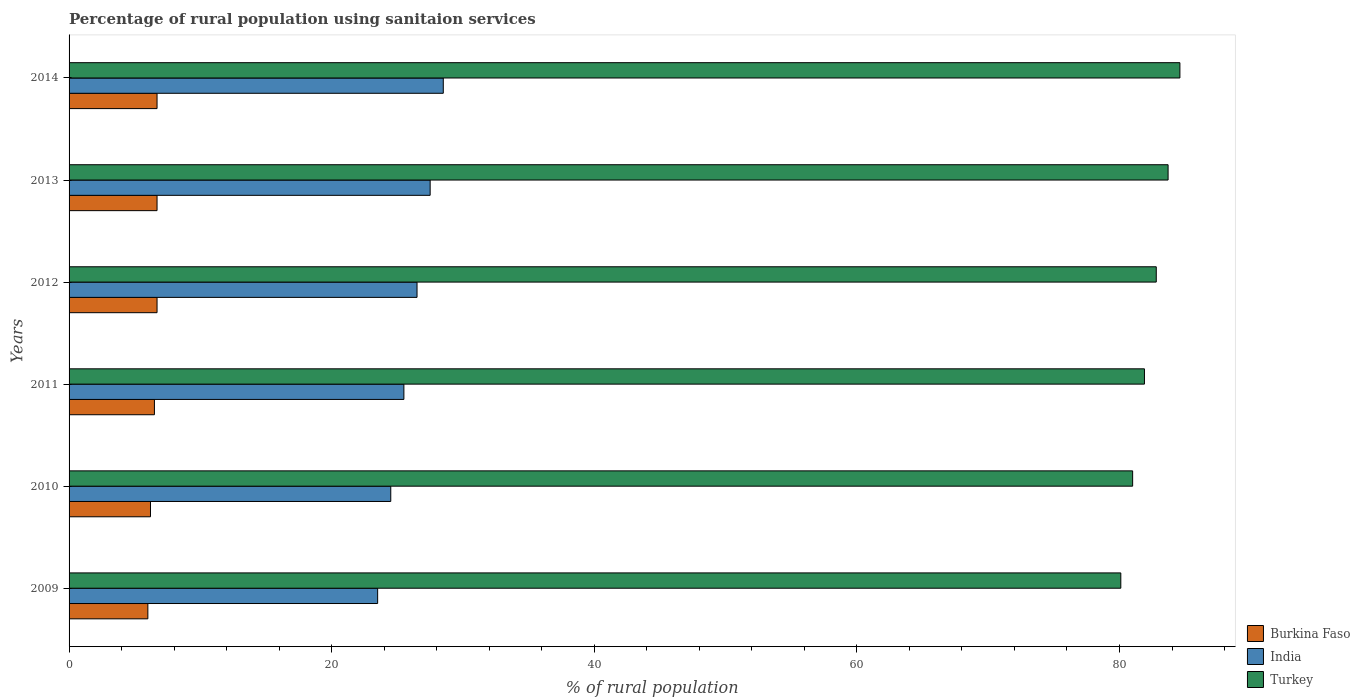Are the number of bars on each tick of the Y-axis equal?
Offer a terse response. Yes. How many bars are there on the 3rd tick from the top?
Your response must be concise. 3. In how many cases, is the number of bars for a given year not equal to the number of legend labels?
Ensure brevity in your answer.  0. What is the percentage of rural population using sanitaion services in India in 2012?
Provide a short and direct response. 26.5. Across all years, what is the maximum percentage of rural population using sanitaion services in Turkey?
Keep it short and to the point. 84.6. Across all years, what is the minimum percentage of rural population using sanitaion services in India?
Give a very brief answer. 23.5. What is the total percentage of rural population using sanitaion services in Burkina Faso in the graph?
Keep it short and to the point. 38.8. What is the difference between the percentage of rural population using sanitaion services in Burkina Faso in 2009 and the percentage of rural population using sanitaion services in Turkey in 2012?
Provide a succinct answer. -76.8. What is the average percentage of rural population using sanitaion services in India per year?
Provide a succinct answer. 26. In the year 2012, what is the difference between the percentage of rural population using sanitaion services in Turkey and percentage of rural population using sanitaion services in India?
Provide a short and direct response. 56.3. In how many years, is the percentage of rural population using sanitaion services in Turkey greater than 8 %?
Your response must be concise. 6. What is the ratio of the percentage of rural population using sanitaion services in Burkina Faso in 2010 to that in 2014?
Provide a short and direct response. 0.93. Is the percentage of rural population using sanitaion services in Burkina Faso in 2009 less than that in 2013?
Your response must be concise. Yes. Is the difference between the percentage of rural population using sanitaion services in Turkey in 2010 and 2011 greater than the difference between the percentage of rural population using sanitaion services in India in 2010 and 2011?
Provide a short and direct response. Yes. What is the difference between the highest and the second highest percentage of rural population using sanitaion services in Turkey?
Give a very brief answer. 0.9. What is the difference between the highest and the lowest percentage of rural population using sanitaion services in Burkina Faso?
Give a very brief answer. 0.7. What does the 1st bar from the bottom in 2013 represents?
Your response must be concise. Burkina Faso. Is it the case that in every year, the sum of the percentage of rural population using sanitaion services in India and percentage of rural population using sanitaion services in Burkina Faso is greater than the percentage of rural population using sanitaion services in Turkey?
Give a very brief answer. No. How many bars are there?
Provide a short and direct response. 18. Are all the bars in the graph horizontal?
Offer a terse response. Yes. What is the difference between two consecutive major ticks on the X-axis?
Make the answer very short. 20. Does the graph contain any zero values?
Ensure brevity in your answer.  No. Does the graph contain grids?
Ensure brevity in your answer.  No. Where does the legend appear in the graph?
Your answer should be compact. Bottom right. How are the legend labels stacked?
Offer a terse response. Vertical. What is the title of the graph?
Ensure brevity in your answer.  Percentage of rural population using sanitaion services. Does "World" appear as one of the legend labels in the graph?
Your answer should be very brief. No. What is the label or title of the X-axis?
Your answer should be compact. % of rural population. What is the label or title of the Y-axis?
Make the answer very short. Years. What is the % of rural population of India in 2009?
Provide a succinct answer. 23.5. What is the % of rural population of Turkey in 2009?
Give a very brief answer. 80.1. What is the % of rural population of India in 2010?
Your response must be concise. 24.5. What is the % of rural population in Turkey in 2011?
Ensure brevity in your answer.  81.9. What is the % of rural population in India in 2012?
Your answer should be very brief. 26.5. What is the % of rural population in Turkey in 2012?
Provide a succinct answer. 82.8. What is the % of rural population in Burkina Faso in 2013?
Your response must be concise. 6.7. What is the % of rural population of India in 2013?
Provide a succinct answer. 27.5. What is the % of rural population of Turkey in 2013?
Provide a succinct answer. 83.7. What is the % of rural population in India in 2014?
Offer a terse response. 28.5. What is the % of rural population in Turkey in 2014?
Ensure brevity in your answer.  84.6. Across all years, what is the maximum % of rural population of Turkey?
Offer a very short reply. 84.6. Across all years, what is the minimum % of rural population of Turkey?
Offer a very short reply. 80.1. What is the total % of rural population of Burkina Faso in the graph?
Your answer should be very brief. 38.8. What is the total % of rural population in India in the graph?
Provide a succinct answer. 156. What is the total % of rural population of Turkey in the graph?
Keep it short and to the point. 494.1. What is the difference between the % of rural population of India in 2009 and that in 2010?
Offer a very short reply. -1. What is the difference between the % of rural population of Turkey in 2009 and that in 2010?
Offer a terse response. -0.9. What is the difference between the % of rural population in Burkina Faso in 2009 and that in 2011?
Make the answer very short. -0.5. What is the difference between the % of rural population of Turkey in 2009 and that in 2011?
Provide a short and direct response. -1.8. What is the difference between the % of rural population of Burkina Faso in 2009 and that in 2012?
Your response must be concise. -0.7. What is the difference between the % of rural population in India in 2009 and that in 2012?
Make the answer very short. -3. What is the difference between the % of rural population of Turkey in 2009 and that in 2012?
Ensure brevity in your answer.  -2.7. What is the difference between the % of rural population of Turkey in 2009 and that in 2013?
Your answer should be compact. -3.6. What is the difference between the % of rural population of Turkey in 2009 and that in 2014?
Your response must be concise. -4.5. What is the difference between the % of rural population of Burkina Faso in 2010 and that in 2011?
Provide a short and direct response. -0.3. What is the difference between the % of rural population in India in 2010 and that in 2011?
Give a very brief answer. -1. What is the difference between the % of rural population in India in 2010 and that in 2012?
Your answer should be compact. -2. What is the difference between the % of rural population in Burkina Faso in 2010 and that in 2013?
Your answer should be very brief. -0.5. What is the difference between the % of rural population of India in 2010 and that in 2013?
Give a very brief answer. -3. What is the difference between the % of rural population in Burkina Faso in 2010 and that in 2014?
Keep it short and to the point. -0.5. What is the difference between the % of rural population in Burkina Faso in 2011 and that in 2012?
Keep it short and to the point. -0.2. What is the difference between the % of rural population of Turkey in 2011 and that in 2013?
Give a very brief answer. -1.8. What is the difference between the % of rural population in India in 2011 and that in 2014?
Your answer should be compact. -3. What is the difference between the % of rural population of Burkina Faso in 2012 and that in 2014?
Offer a terse response. 0. What is the difference between the % of rural population in Burkina Faso in 2013 and that in 2014?
Keep it short and to the point. 0. What is the difference between the % of rural population of India in 2013 and that in 2014?
Ensure brevity in your answer.  -1. What is the difference between the % of rural population in Burkina Faso in 2009 and the % of rural population in India in 2010?
Provide a succinct answer. -18.5. What is the difference between the % of rural population in Burkina Faso in 2009 and the % of rural population in Turkey in 2010?
Keep it short and to the point. -75. What is the difference between the % of rural population in India in 2009 and the % of rural population in Turkey in 2010?
Your response must be concise. -57.5. What is the difference between the % of rural population of Burkina Faso in 2009 and the % of rural population of India in 2011?
Offer a terse response. -19.5. What is the difference between the % of rural population in Burkina Faso in 2009 and the % of rural population in Turkey in 2011?
Your answer should be very brief. -75.9. What is the difference between the % of rural population of India in 2009 and the % of rural population of Turkey in 2011?
Your answer should be very brief. -58.4. What is the difference between the % of rural population of Burkina Faso in 2009 and the % of rural population of India in 2012?
Your answer should be compact. -20.5. What is the difference between the % of rural population of Burkina Faso in 2009 and the % of rural population of Turkey in 2012?
Your response must be concise. -76.8. What is the difference between the % of rural population of India in 2009 and the % of rural population of Turkey in 2012?
Ensure brevity in your answer.  -59.3. What is the difference between the % of rural population of Burkina Faso in 2009 and the % of rural population of India in 2013?
Your answer should be compact. -21.5. What is the difference between the % of rural population of Burkina Faso in 2009 and the % of rural population of Turkey in 2013?
Provide a short and direct response. -77.7. What is the difference between the % of rural population in India in 2009 and the % of rural population in Turkey in 2013?
Provide a succinct answer. -60.2. What is the difference between the % of rural population in Burkina Faso in 2009 and the % of rural population in India in 2014?
Give a very brief answer. -22.5. What is the difference between the % of rural population of Burkina Faso in 2009 and the % of rural population of Turkey in 2014?
Offer a terse response. -78.6. What is the difference between the % of rural population of India in 2009 and the % of rural population of Turkey in 2014?
Ensure brevity in your answer.  -61.1. What is the difference between the % of rural population of Burkina Faso in 2010 and the % of rural population of India in 2011?
Offer a very short reply. -19.3. What is the difference between the % of rural population of Burkina Faso in 2010 and the % of rural population of Turkey in 2011?
Your answer should be compact. -75.7. What is the difference between the % of rural population in India in 2010 and the % of rural population in Turkey in 2011?
Provide a succinct answer. -57.4. What is the difference between the % of rural population of Burkina Faso in 2010 and the % of rural population of India in 2012?
Provide a short and direct response. -20.3. What is the difference between the % of rural population of Burkina Faso in 2010 and the % of rural population of Turkey in 2012?
Your response must be concise. -76.6. What is the difference between the % of rural population of India in 2010 and the % of rural population of Turkey in 2012?
Keep it short and to the point. -58.3. What is the difference between the % of rural population of Burkina Faso in 2010 and the % of rural population of India in 2013?
Your answer should be compact. -21.3. What is the difference between the % of rural population in Burkina Faso in 2010 and the % of rural population in Turkey in 2013?
Ensure brevity in your answer.  -77.5. What is the difference between the % of rural population in India in 2010 and the % of rural population in Turkey in 2013?
Keep it short and to the point. -59.2. What is the difference between the % of rural population of Burkina Faso in 2010 and the % of rural population of India in 2014?
Your answer should be very brief. -22.3. What is the difference between the % of rural population of Burkina Faso in 2010 and the % of rural population of Turkey in 2014?
Give a very brief answer. -78.4. What is the difference between the % of rural population in India in 2010 and the % of rural population in Turkey in 2014?
Ensure brevity in your answer.  -60.1. What is the difference between the % of rural population in Burkina Faso in 2011 and the % of rural population in Turkey in 2012?
Your response must be concise. -76.3. What is the difference between the % of rural population in India in 2011 and the % of rural population in Turkey in 2012?
Provide a short and direct response. -57.3. What is the difference between the % of rural population in Burkina Faso in 2011 and the % of rural population in India in 2013?
Provide a short and direct response. -21. What is the difference between the % of rural population in Burkina Faso in 2011 and the % of rural population in Turkey in 2013?
Your answer should be compact. -77.2. What is the difference between the % of rural population of India in 2011 and the % of rural population of Turkey in 2013?
Ensure brevity in your answer.  -58.2. What is the difference between the % of rural population of Burkina Faso in 2011 and the % of rural population of Turkey in 2014?
Offer a terse response. -78.1. What is the difference between the % of rural population in India in 2011 and the % of rural population in Turkey in 2014?
Offer a very short reply. -59.1. What is the difference between the % of rural population of Burkina Faso in 2012 and the % of rural population of India in 2013?
Keep it short and to the point. -20.8. What is the difference between the % of rural population of Burkina Faso in 2012 and the % of rural population of Turkey in 2013?
Keep it short and to the point. -77. What is the difference between the % of rural population of India in 2012 and the % of rural population of Turkey in 2013?
Provide a succinct answer. -57.2. What is the difference between the % of rural population in Burkina Faso in 2012 and the % of rural population in India in 2014?
Your answer should be compact. -21.8. What is the difference between the % of rural population of Burkina Faso in 2012 and the % of rural population of Turkey in 2014?
Give a very brief answer. -77.9. What is the difference between the % of rural population in India in 2012 and the % of rural population in Turkey in 2014?
Your answer should be compact. -58.1. What is the difference between the % of rural population in Burkina Faso in 2013 and the % of rural population in India in 2014?
Give a very brief answer. -21.8. What is the difference between the % of rural population in Burkina Faso in 2013 and the % of rural population in Turkey in 2014?
Keep it short and to the point. -77.9. What is the difference between the % of rural population in India in 2013 and the % of rural population in Turkey in 2014?
Provide a short and direct response. -57.1. What is the average % of rural population in Burkina Faso per year?
Keep it short and to the point. 6.47. What is the average % of rural population in Turkey per year?
Provide a short and direct response. 82.35. In the year 2009, what is the difference between the % of rural population in Burkina Faso and % of rural population in India?
Ensure brevity in your answer.  -17.5. In the year 2009, what is the difference between the % of rural population in Burkina Faso and % of rural population in Turkey?
Your answer should be very brief. -74.1. In the year 2009, what is the difference between the % of rural population of India and % of rural population of Turkey?
Provide a short and direct response. -56.6. In the year 2010, what is the difference between the % of rural population of Burkina Faso and % of rural population of India?
Offer a terse response. -18.3. In the year 2010, what is the difference between the % of rural population in Burkina Faso and % of rural population in Turkey?
Ensure brevity in your answer.  -74.8. In the year 2010, what is the difference between the % of rural population in India and % of rural population in Turkey?
Give a very brief answer. -56.5. In the year 2011, what is the difference between the % of rural population in Burkina Faso and % of rural population in India?
Provide a short and direct response. -19. In the year 2011, what is the difference between the % of rural population in Burkina Faso and % of rural population in Turkey?
Your answer should be very brief. -75.4. In the year 2011, what is the difference between the % of rural population of India and % of rural population of Turkey?
Your answer should be compact. -56.4. In the year 2012, what is the difference between the % of rural population of Burkina Faso and % of rural population of India?
Give a very brief answer. -19.8. In the year 2012, what is the difference between the % of rural population of Burkina Faso and % of rural population of Turkey?
Your response must be concise. -76.1. In the year 2012, what is the difference between the % of rural population in India and % of rural population in Turkey?
Your answer should be compact. -56.3. In the year 2013, what is the difference between the % of rural population in Burkina Faso and % of rural population in India?
Provide a succinct answer. -20.8. In the year 2013, what is the difference between the % of rural population of Burkina Faso and % of rural population of Turkey?
Your answer should be compact. -77. In the year 2013, what is the difference between the % of rural population of India and % of rural population of Turkey?
Your answer should be very brief. -56.2. In the year 2014, what is the difference between the % of rural population of Burkina Faso and % of rural population of India?
Your answer should be very brief. -21.8. In the year 2014, what is the difference between the % of rural population of Burkina Faso and % of rural population of Turkey?
Your answer should be compact. -77.9. In the year 2014, what is the difference between the % of rural population of India and % of rural population of Turkey?
Ensure brevity in your answer.  -56.1. What is the ratio of the % of rural population of India in 2009 to that in 2010?
Your response must be concise. 0.96. What is the ratio of the % of rural population of Turkey in 2009 to that in 2010?
Your answer should be very brief. 0.99. What is the ratio of the % of rural population in Burkina Faso in 2009 to that in 2011?
Offer a terse response. 0.92. What is the ratio of the % of rural population in India in 2009 to that in 2011?
Ensure brevity in your answer.  0.92. What is the ratio of the % of rural population of Burkina Faso in 2009 to that in 2012?
Provide a succinct answer. 0.9. What is the ratio of the % of rural population in India in 2009 to that in 2012?
Give a very brief answer. 0.89. What is the ratio of the % of rural population in Turkey in 2009 to that in 2012?
Your response must be concise. 0.97. What is the ratio of the % of rural population in Burkina Faso in 2009 to that in 2013?
Provide a short and direct response. 0.9. What is the ratio of the % of rural population of India in 2009 to that in 2013?
Offer a very short reply. 0.85. What is the ratio of the % of rural population in Turkey in 2009 to that in 2013?
Provide a succinct answer. 0.96. What is the ratio of the % of rural population in Burkina Faso in 2009 to that in 2014?
Offer a very short reply. 0.9. What is the ratio of the % of rural population in India in 2009 to that in 2014?
Your response must be concise. 0.82. What is the ratio of the % of rural population in Turkey in 2009 to that in 2014?
Provide a short and direct response. 0.95. What is the ratio of the % of rural population of Burkina Faso in 2010 to that in 2011?
Provide a short and direct response. 0.95. What is the ratio of the % of rural population in India in 2010 to that in 2011?
Give a very brief answer. 0.96. What is the ratio of the % of rural population in Turkey in 2010 to that in 2011?
Offer a terse response. 0.99. What is the ratio of the % of rural population of Burkina Faso in 2010 to that in 2012?
Your response must be concise. 0.93. What is the ratio of the % of rural population of India in 2010 to that in 2012?
Make the answer very short. 0.92. What is the ratio of the % of rural population of Turkey in 2010 to that in 2012?
Your answer should be very brief. 0.98. What is the ratio of the % of rural population in Burkina Faso in 2010 to that in 2013?
Your response must be concise. 0.93. What is the ratio of the % of rural population of India in 2010 to that in 2013?
Your answer should be very brief. 0.89. What is the ratio of the % of rural population in Burkina Faso in 2010 to that in 2014?
Your response must be concise. 0.93. What is the ratio of the % of rural population in India in 2010 to that in 2014?
Your response must be concise. 0.86. What is the ratio of the % of rural population in Turkey in 2010 to that in 2014?
Offer a very short reply. 0.96. What is the ratio of the % of rural population of Burkina Faso in 2011 to that in 2012?
Offer a very short reply. 0.97. What is the ratio of the % of rural population of India in 2011 to that in 2012?
Provide a short and direct response. 0.96. What is the ratio of the % of rural population in Burkina Faso in 2011 to that in 2013?
Your answer should be very brief. 0.97. What is the ratio of the % of rural population in India in 2011 to that in 2013?
Make the answer very short. 0.93. What is the ratio of the % of rural population in Turkey in 2011 to that in 2013?
Give a very brief answer. 0.98. What is the ratio of the % of rural population of Burkina Faso in 2011 to that in 2014?
Make the answer very short. 0.97. What is the ratio of the % of rural population of India in 2011 to that in 2014?
Give a very brief answer. 0.89. What is the ratio of the % of rural population of Turkey in 2011 to that in 2014?
Offer a terse response. 0.97. What is the ratio of the % of rural population in Burkina Faso in 2012 to that in 2013?
Provide a succinct answer. 1. What is the ratio of the % of rural population of India in 2012 to that in 2013?
Provide a succinct answer. 0.96. What is the ratio of the % of rural population of Turkey in 2012 to that in 2013?
Your response must be concise. 0.99. What is the ratio of the % of rural population in Burkina Faso in 2012 to that in 2014?
Give a very brief answer. 1. What is the ratio of the % of rural population in India in 2012 to that in 2014?
Provide a succinct answer. 0.93. What is the ratio of the % of rural population in Turkey in 2012 to that in 2014?
Make the answer very short. 0.98. What is the ratio of the % of rural population in India in 2013 to that in 2014?
Provide a short and direct response. 0.96. What is the difference between the highest and the second highest % of rural population in Burkina Faso?
Offer a very short reply. 0. What is the difference between the highest and the second highest % of rural population of Turkey?
Your answer should be compact. 0.9. What is the difference between the highest and the lowest % of rural population in Burkina Faso?
Provide a short and direct response. 0.7. What is the difference between the highest and the lowest % of rural population of Turkey?
Your response must be concise. 4.5. 